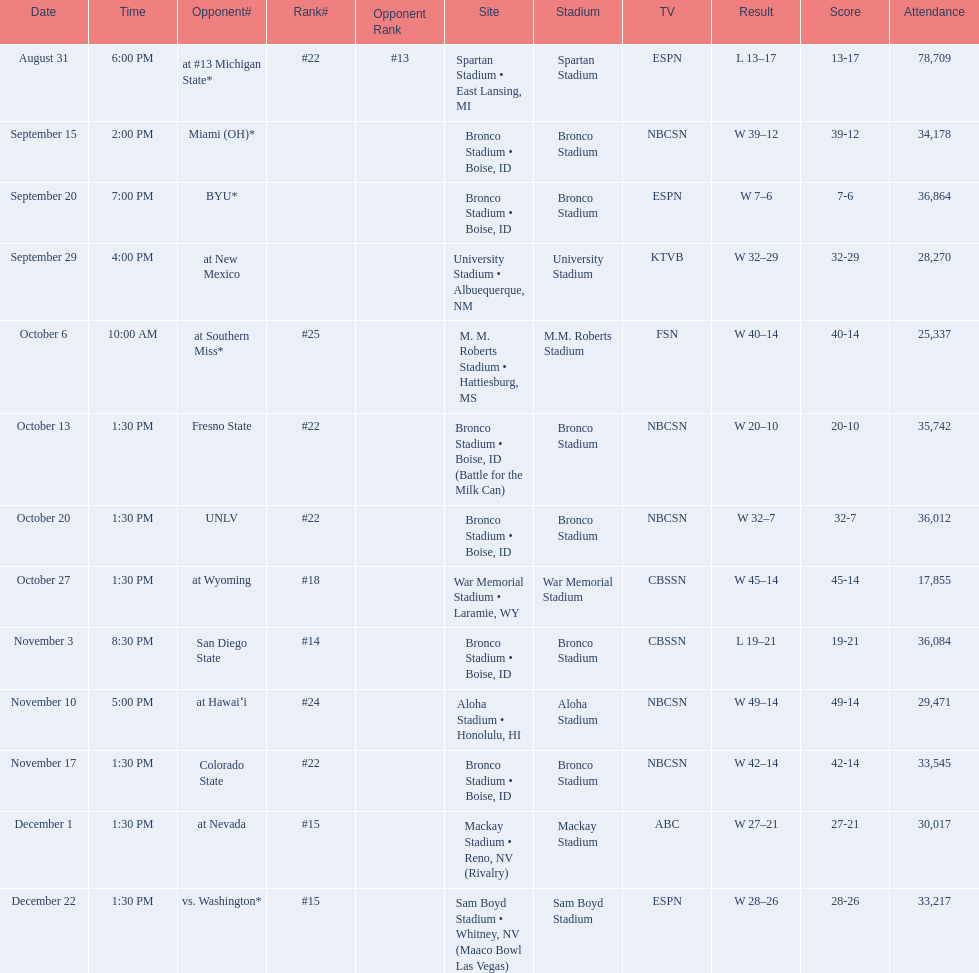Which team has the highest rank among those listed? San Diego State. 